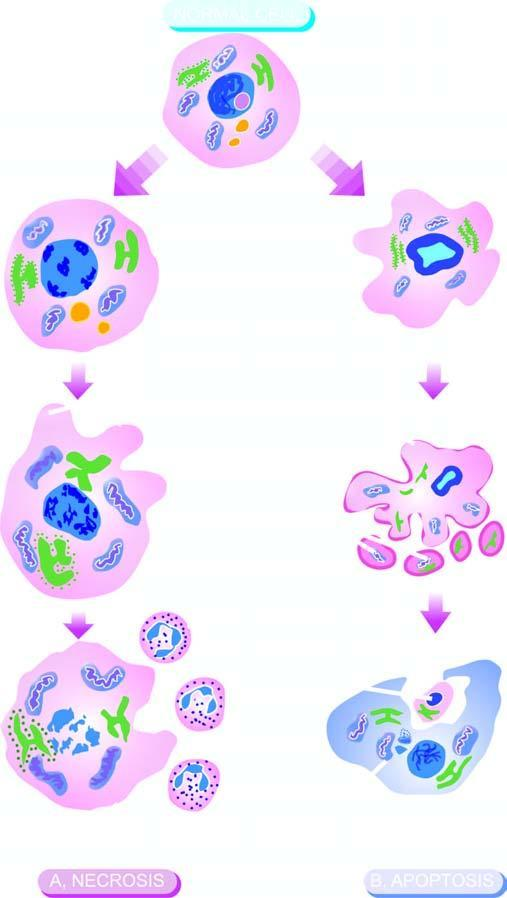what is cell necrosis identified by?
Answer the question using a single word or phrase. Homogeneous 